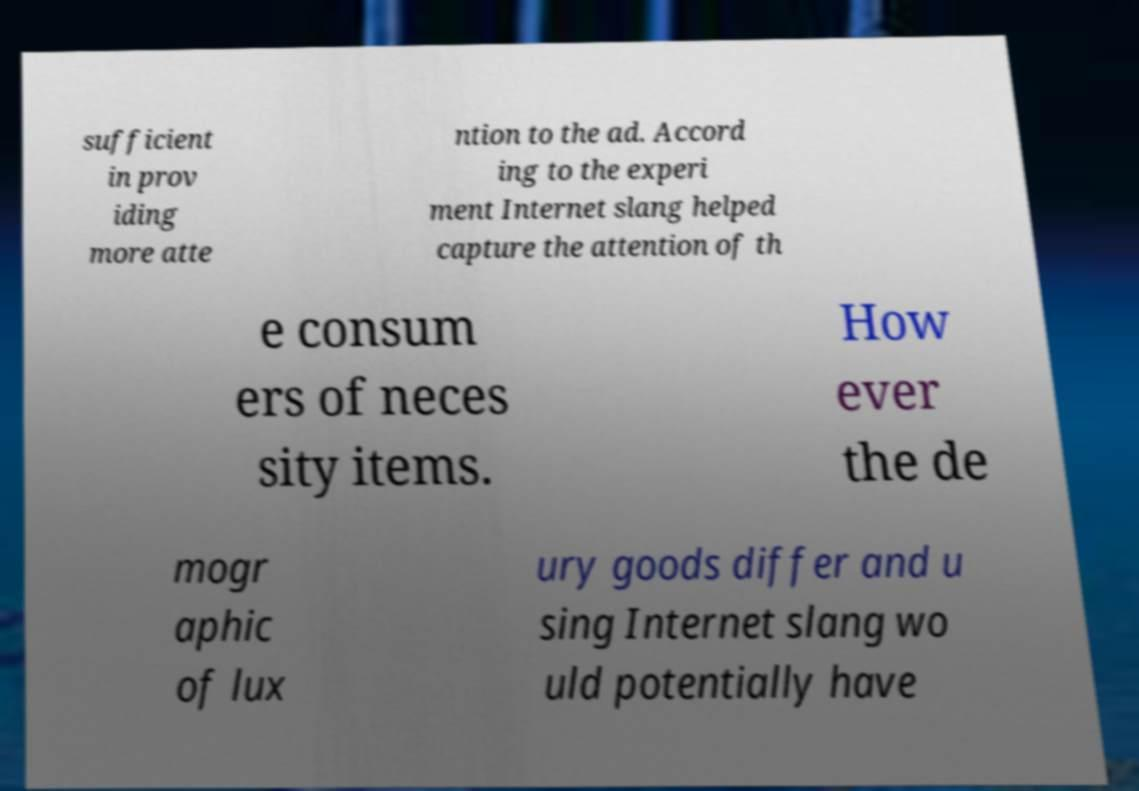There's text embedded in this image that I need extracted. Can you transcribe it verbatim? sufficient in prov iding more atte ntion to the ad. Accord ing to the experi ment Internet slang helped capture the attention of th e consum ers of neces sity items. How ever the de mogr aphic of lux ury goods differ and u sing Internet slang wo uld potentially have 